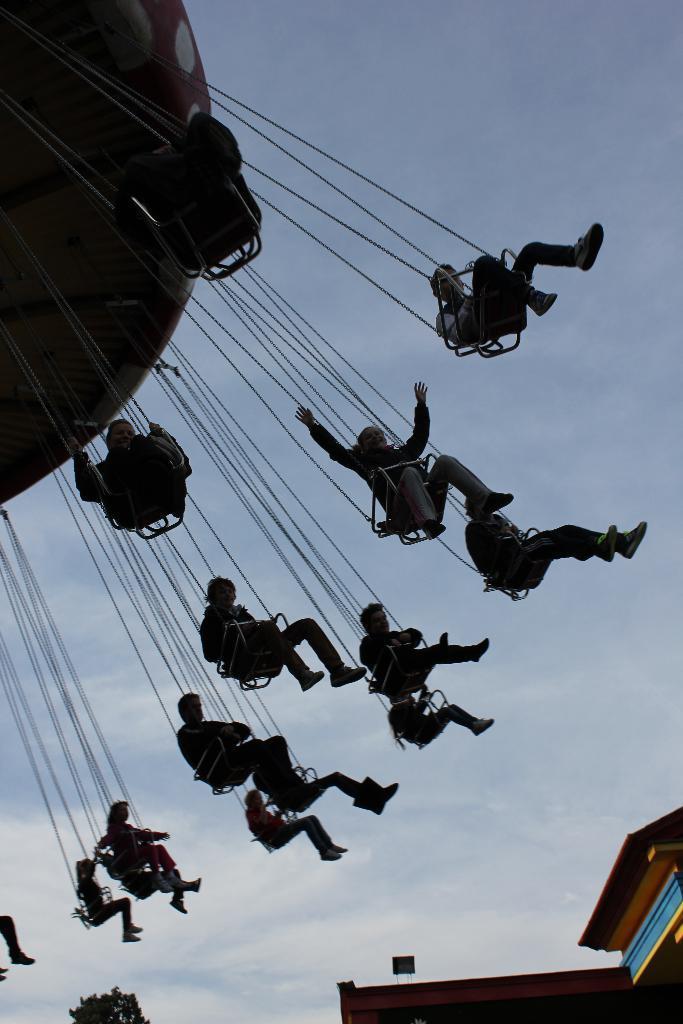Describe this image in one or two sentences. In this image, we can see few people are playing a ride. They are sitting on the seats. Background there is a sky. At the bottom, we can see tree and wall. 